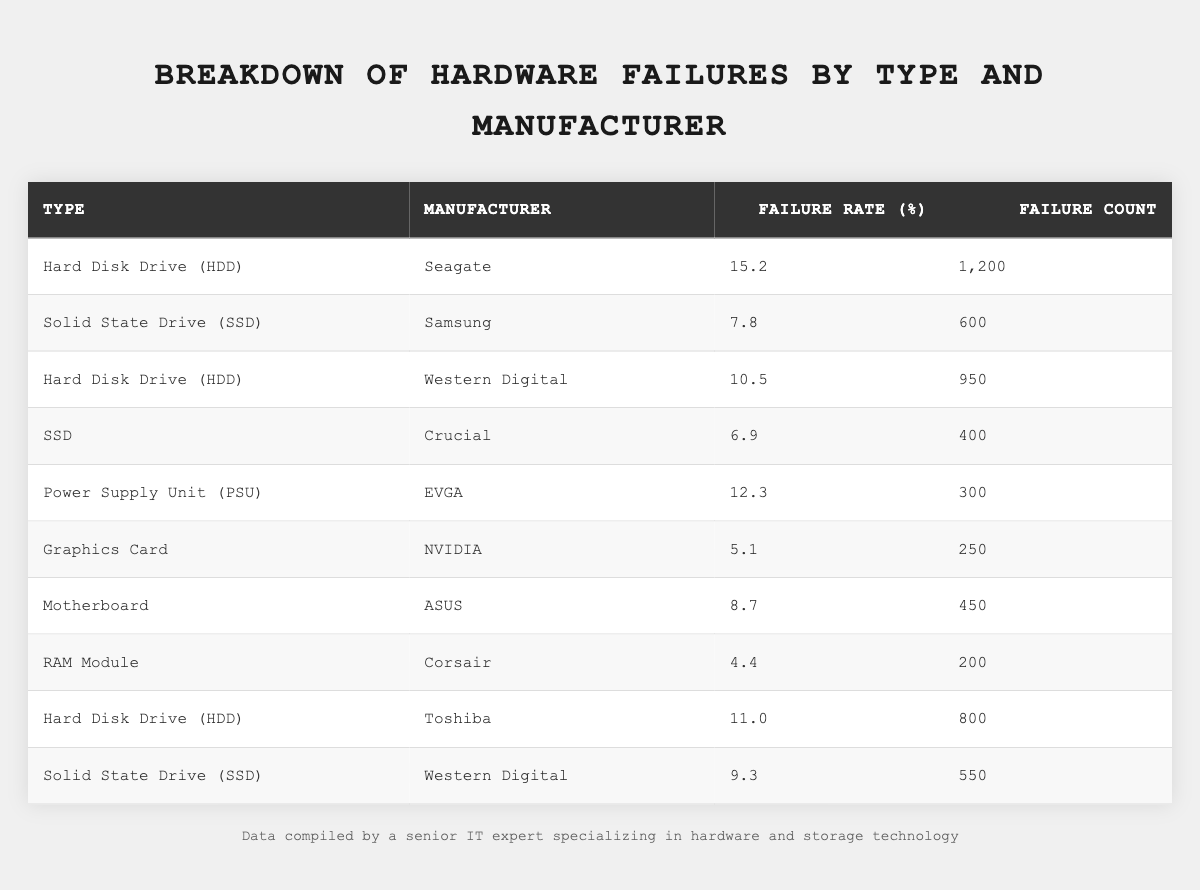What is the failure rate of Seagate hard drives? The table lists the failure rate for Seagate under the "Hard Disk Drive (HDD)" type, which is indicated as 15.2%.
Answer: 15.2% Which manufacturer has the highest failure count? By examining the failure counts, Seagate has the highest count of 1,200 compared to other manufacturers.
Answer: Seagate What is the total failure count for all SSDs? The failure counts for SSDs are 600 (Samsung) + 400 (Crucial) + 550 (Western Digital) = 1,550.
Answer: 1,550 Is the failure rate of NVIDIA graphics cards less than 7%? The table shows NVIDIA's failure rate as 5.1%, which is indeed less than 7%.
Answer: Yes What is the average failure rate of HDDs? The failure rates of HDDs are 15.2% (Seagate), 10.5% (Western Digital), 11.0% (Toshiba), so the average is (15.2 + 10.5 + 11.0) / 3 = 12.23%.
Answer: 12.23% How many more HDD failures were reported for Seagate compared to Western Digital? Seagate has 1,200 failures, while Western Digital has 950, resulting in a difference of 1,200 - 950 = 250 failures.
Answer: 250 Which has a higher failure rate: Western Digital SSDs or Crucial SSDs? Western Digital SSDs have a failure rate of 9.3%, while Crucial SSDs have a rate of 6.9%, indicating that Western Digital SSDs have a higher failure rate.
Answer: Western Digital SSDs What percentage of the total failures do power supply units account for? The total failure count is 1200 (Seagate) + 600 (Samsung) + 950 (Western Digital) + 400 (Crucial) + 300 (EVGA) + 250 (NVIDIA) + 450 (ASUS) + 200 (Corsair) + 800 (Toshiba) + 550 (Western Digital SSD) = 5,650. EVGA power supply units account for 300 failures, which is (300 / 5650) * 100 ≈ 5.31%.
Answer: Approximately 5.31% Which hardware type has the lowest failure rate? By comparing the failure rates from the table, RAM Module (Corsair) has the lowest rate at 4.4%.
Answer: RAM Module What is the total number of failures for all manufacturers combined? By summing all the failure counts from each manufacturer: 1200 + 600 + 950 + 400 + 300 + 250 + 450 + 200 + 800 + 550 = 5,650.
Answer: 5,650 